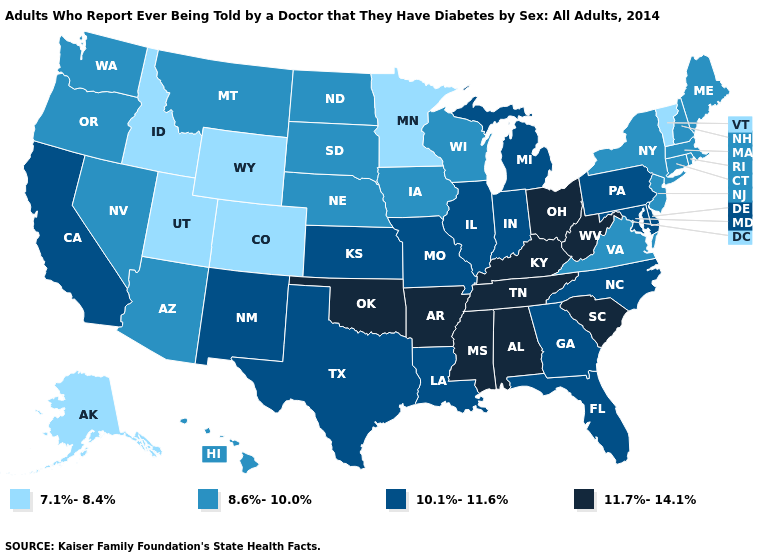What is the value of Maine?
Quick response, please. 8.6%-10.0%. What is the value of New Mexico?
Be succinct. 10.1%-11.6%. What is the value of New Mexico?
Concise answer only. 10.1%-11.6%. Which states have the highest value in the USA?
Answer briefly. Alabama, Arkansas, Kentucky, Mississippi, Ohio, Oklahoma, South Carolina, Tennessee, West Virginia. What is the highest value in the West ?
Be succinct. 10.1%-11.6%. Among the states that border Florida , which have the lowest value?
Give a very brief answer. Georgia. Name the states that have a value in the range 8.6%-10.0%?
Answer briefly. Arizona, Connecticut, Hawaii, Iowa, Maine, Massachusetts, Montana, Nebraska, Nevada, New Hampshire, New Jersey, New York, North Dakota, Oregon, Rhode Island, South Dakota, Virginia, Washington, Wisconsin. Name the states that have a value in the range 11.7%-14.1%?
Quick response, please. Alabama, Arkansas, Kentucky, Mississippi, Ohio, Oklahoma, South Carolina, Tennessee, West Virginia. Does Oklahoma have the highest value in the USA?
Quick response, please. Yes. Does Nebraska have the lowest value in the MidWest?
Give a very brief answer. No. What is the value of Maine?
Write a very short answer. 8.6%-10.0%. Which states hav the highest value in the MidWest?
Short answer required. Ohio. What is the value of North Carolina?
Concise answer only. 10.1%-11.6%. 